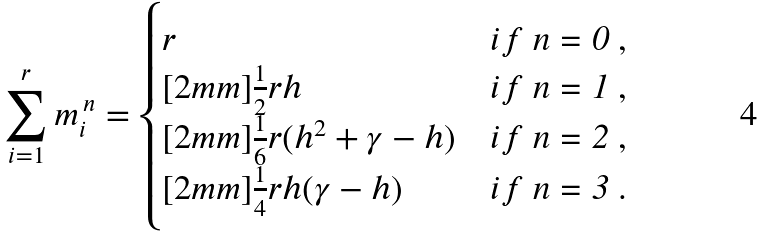Convert formula to latex. <formula><loc_0><loc_0><loc_500><loc_500>\sum _ { i = 1 } ^ { r } m _ { i } ^ { \, n } = \begin{cases} r & i f $ n = 0 $ , \\ [ 2 m m ] \frac { 1 } { 2 } r h & i f $ n = 1 $ , \\ [ 2 m m ] \frac { 1 } { 6 } r ( h ^ { 2 } + \gamma - h ) & i f $ n = 2 $ , \\ [ 2 m m ] \frac { 1 } { 4 } r h ( \gamma - h ) & i f $ n = 3 $ . \end{cases}</formula> 